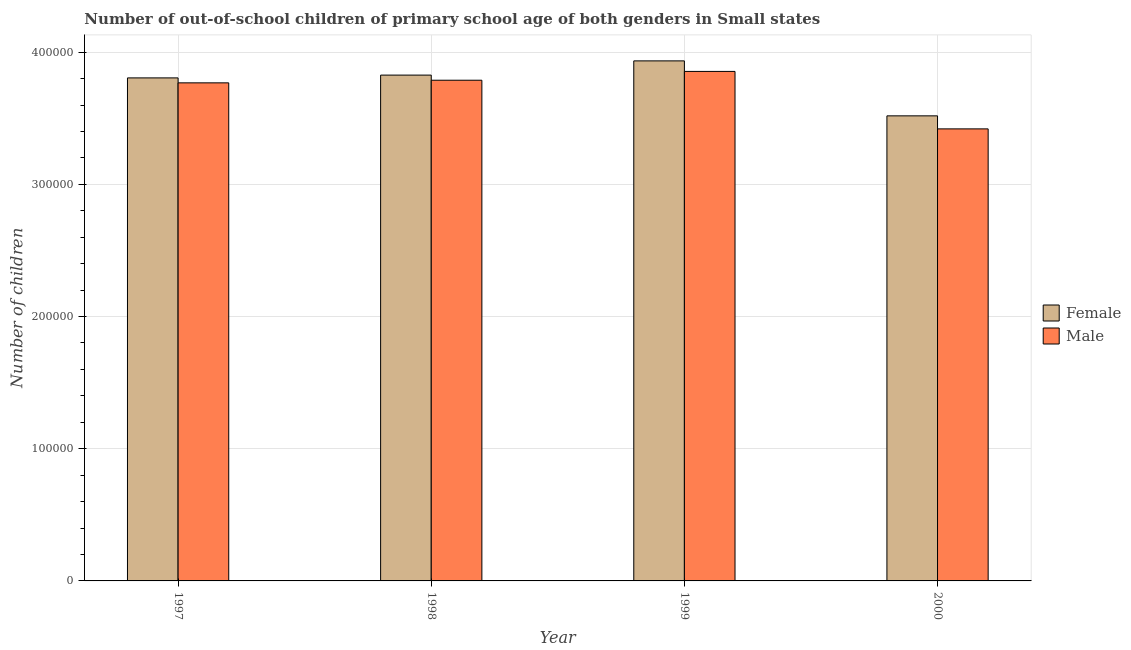How many groups of bars are there?
Your response must be concise. 4. Are the number of bars per tick equal to the number of legend labels?
Provide a succinct answer. Yes. How many bars are there on the 1st tick from the left?
Your answer should be compact. 2. In how many cases, is the number of bars for a given year not equal to the number of legend labels?
Give a very brief answer. 0. What is the number of male out-of-school students in 2000?
Your response must be concise. 3.42e+05. Across all years, what is the maximum number of male out-of-school students?
Your answer should be compact. 3.85e+05. Across all years, what is the minimum number of male out-of-school students?
Give a very brief answer. 3.42e+05. In which year was the number of female out-of-school students maximum?
Provide a short and direct response. 1999. In which year was the number of male out-of-school students minimum?
Offer a terse response. 2000. What is the total number of male out-of-school students in the graph?
Your response must be concise. 1.48e+06. What is the difference between the number of male out-of-school students in 1998 and that in 1999?
Your response must be concise. -6673. What is the difference between the number of female out-of-school students in 2000 and the number of male out-of-school students in 1997?
Your answer should be very brief. -2.87e+04. What is the average number of female out-of-school students per year?
Keep it short and to the point. 3.77e+05. In the year 2000, what is the difference between the number of male out-of-school students and number of female out-of-school students?
Your response must be concise. 0. What is the ratio of the number of male out-of-school students in 1997 to that in 1998?
Give a very brief answer. 0.99. Is the number of male out-of-school students in 1998 less than that in 2000?
Keep it short and to the point. No. Is the difference between the number of male out-of-school students in 1998 and 1999 greater than the difference between the number of female out-of-school students in 1998 and 1999?
Make the answer very short. No. What is the difference between the highest and the second highest number of female out-of-school students?
Ensure brevity in your answer.  1.08e+04. What is the difference between the highest and the lowest number of female out-of-school students?
Offer a very short reply. 4.16e+04. In how many years, is the number of male out-of-school students greater than the average number of male out-of-school students taken over all years?
Keep it short and to the point. 3. What does the 1st bar from the left in 2000 represents?
Your answer should be compact. Female. How many bars are there?
Provide a succinct answer. 8. Are all the bars in the graph horizontal?
Offer a very short reply. No. What is the difference between two consecutive major ticks on the Y-axis?
Your answer should be very brief. 1.00e+05. How many legend labels are there?
Keep it short and to the point. 2. What is the title of the graph?
Your response must be concise. Number of out-of-school children of primary school age of both genders in Small states. What is the label or title of the Y-axis?
Your response must be concise. Number of children. What is the Number of children in Female in 1997?
Provide a succinct answer. 3.81e+05. What is the Number of children of Male in 1997?
Keep it short and to the point. 3.77e+05. What is the Number of children in Female in 1998?
Give a very brief answer. 3.83e+05. What is the Number of children of Male in 1998?
Offer a very short reply. 3.79e+05. What is the Number of children of Female in 1999?
Provide a short and direct response. 3.93e+05. What is the Number of children in Male in 1999?
Offer a very short reply. 3.85e+05. What is the Number of children in Female in 2000?
Offer a terse response. 3.52e+05. What is the Number of children of Male in 2000?
Give a very brief answer. 3.42e+05. Across all years, what is the maximum Number of children of Female?
Your answer should be very brief. 3.93e+05. Across all years, what is the maximum Number of children of Male?
Your answer should be compact. 3.85e+05. Across all years, what is the minimum Number of children of Female?
Your response must be concise. 3.52e+05. Across all years, what is the minimum Number of children in Male?
Make the answer very short. 3.42e+05. What is the total Number of children in Female in the graph?
Your answer should be very brief. 1.51e+06. What is the total Number of children of Male in the graph?
Your answer should be very brief. 1.48e+06. What is the difference between the Number of children in Female in 1997 and that in 1998?
Your answer should be compact. -2115. What is the difference between the Number of children in Male in 1997 and that in 1998?
Keep it short and to the point. -1983. What is the difference between the Number of children in Female in 1997 and that in 1999?
Your answer should be compact. -1.29e+04. What is the difference between the Number of children in Male in 1997 and that in 1999?
Ensure brevity in your answer.  -8656. What is the difference between the Number of children in Female in 1997 and that in 2000?
Make the answer very short. 2.87e+04. What is the difference between the Number of children in Male in 1997 and that in 2000?
Ensure brevity in your answer.  3.48e+04. What is the difference between the Number of children of Female in 1998 and that in 1999?
Your response must be concise. -1.08e+04. What is the difference between the Number of children of Male in 1998 and that in 1999?
Your response must be concise. -6673. What is the difference between the Number of children in Female in 1998 and that in 2000?
Your answer should be compact. 3.08e+04. What is the difference between the Number of children in Male in 1998 and that in 2000?
Your answer should be very brief. 3.68e+04. What is the difference between the Number of children of Female in 1999 and that in 2000?
Offer a very short reply. 4.16e+04. What is the difference between the Number of children in Male in 1999 and that in 2000?
Make the answer very short. 4.35e+04. What is the difference between the Number of children in Female in 1997 and the Number of children in Male in 1998?
Keep it short and to the point. 1767. What is the difference between the Number of children in Female in 1997 and the Number of children in Male in 1999?
Give a very brief answer. -4906. What is the difference between the Number of children in Female in 1997 and the Number of children in Male in 2000?
Your response must be concise. 3.86e+04. What is the difference between the Number of children of Female in 1998 and the Number of children of Male in 1999?
Make the answer very short. -2791. What is the difference between the Number of children in Female in 1998 and the Number of children in Male in 2000?
Offer a terse response. 4.07e+04. What is the difference between the Number of children of Female in 1999 and the Number of children of Male in 2000?
Offer a very short reply. 5.14e+04. What is the average Number of children in Female per year?
Your response must be concise. 3.77e+05. What is the average Number of children in Male per year?
Your answer should be compact. 3.71e+05. In the year 1997, what is the difference between the Number of children in Female and Number of children in Male?
Ensure brevity in your answer.  3750. In the year 1998, what is the difference between the Number of children in Female and Number of children in Male?
Provide a short and direct response. 3882. In the year 1999, what is the difference between the Number of children in Female and Number of children in Male?
Your answer should be very brief. 7967. In the year 2000, what is the difference between the Number of children in Female and Number of children in Male?
Offer a terse response. 9850. What is the ratio of the Number of children in Male in 1997 to that in 1998?
Keep it short and to the point. 0.99. What is the ratio of the Number of children in Female in 1997 to that in 1999?
Your answer should be very brief. 0.97. What is the ratio of the Number of children of Male in 1997 to that in 1999?
Make the answer very short. 0.98. What is the ratio of the Number of children of Female in 1997 to that in 2000?
Ensure brevity in your answer.  1.08. What is the ratio of the Number of children in Male in 1997 to that in 2000?
Give a very brief answer. 1.1. What is the ratio of the Number of children of Female in 1998 to that in 1999?
Your response must be concise. 0.97. What is the ratio of the Number of children in Male in 1998 to that in 1999?
Offer a very short reply. 0.98. What is the ratio of the Number of children in Female in 1998 to that in 2000?
Your answer should be very brief. 1.09. What is the ratio of the Number of children in Male in 1998 to that in 2000?
Give a very brief answer. 1.11. What is the ratio of the Number of children in Female in 1999 to that in 2000?
Offer a terse response. 1.12. What is the ratio of the Number of children of Male in 1999 to that in 2000?
Provide a succinct answer. 1.13. What is the difference between the highest and the second highest Number of children in Female?
Provide a short and direct response. 1.08e+04. What is the difference between the highest and the second highest Number of children of Male?
Ensure brevity in your answer.  6673. What is the difference between the highest and the lowest Number of children in Female?
Keep it short and to the point. 4.16e+04. What is the difference between the highest and the lowest Number of children in Male?
Your answer should be very brief. 4.35e+04. 